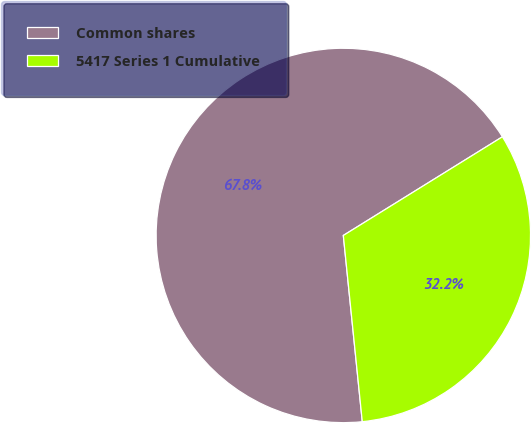Convert chart. <chart><loc_0><loc_0><loc_500><loc_500><pie_chart><fcel>Common shares<fcel>5417 Series 1 Cumulative<nl><fcel>67.78%<fcel>32.22%<nl></chart> 